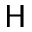<formula> <loc_0><loc_0><loc_500><loc_500>H</formula> 